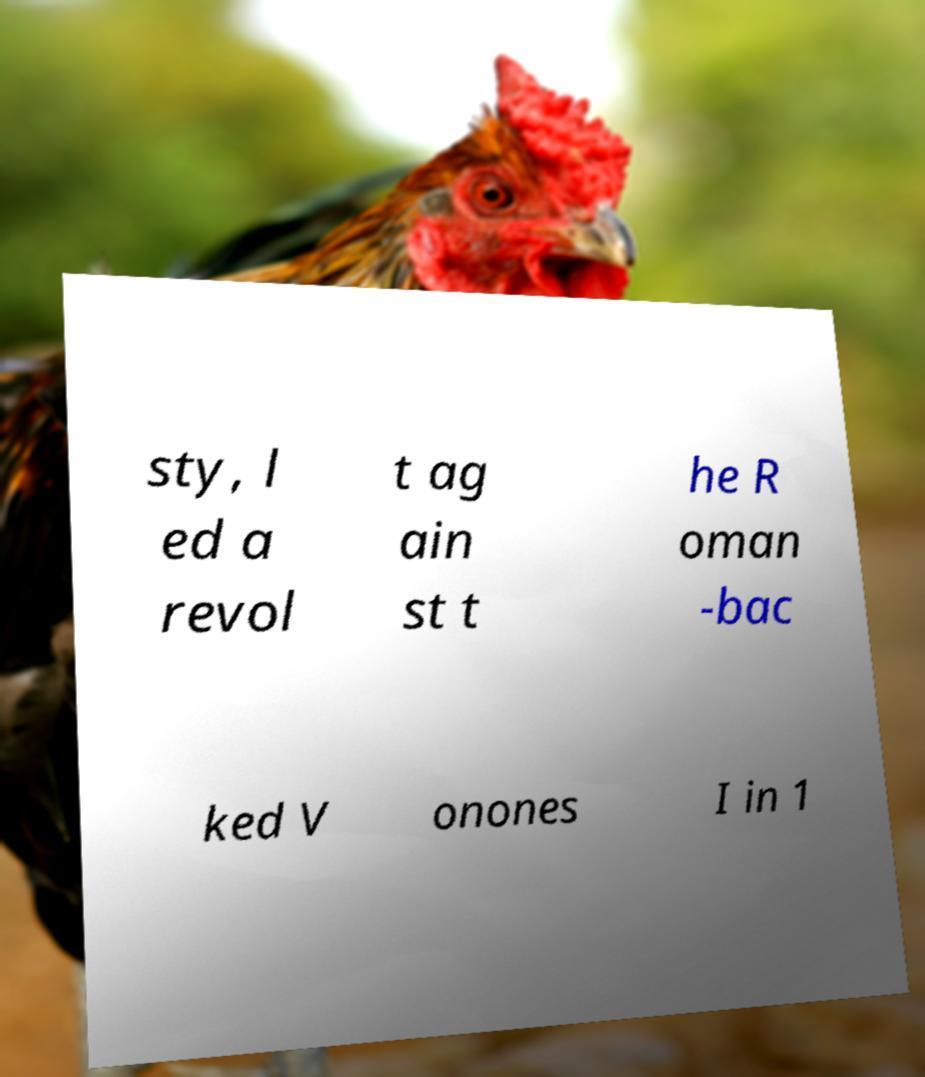I need the written content from this picture converted into text. Can you do that? sty, l ed a revol t ag ain st t he R oman -bac ked V onones I in 1 